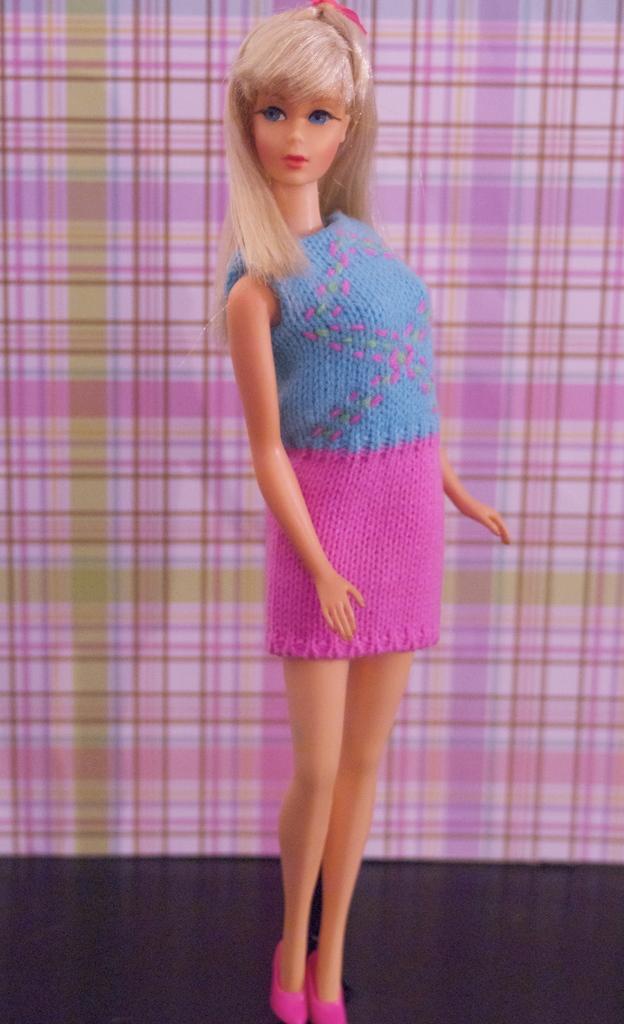Please provide a concise description of this image. In this picture we can see a Barbie doll standing on the black floor in front of a pink & green cloth. 